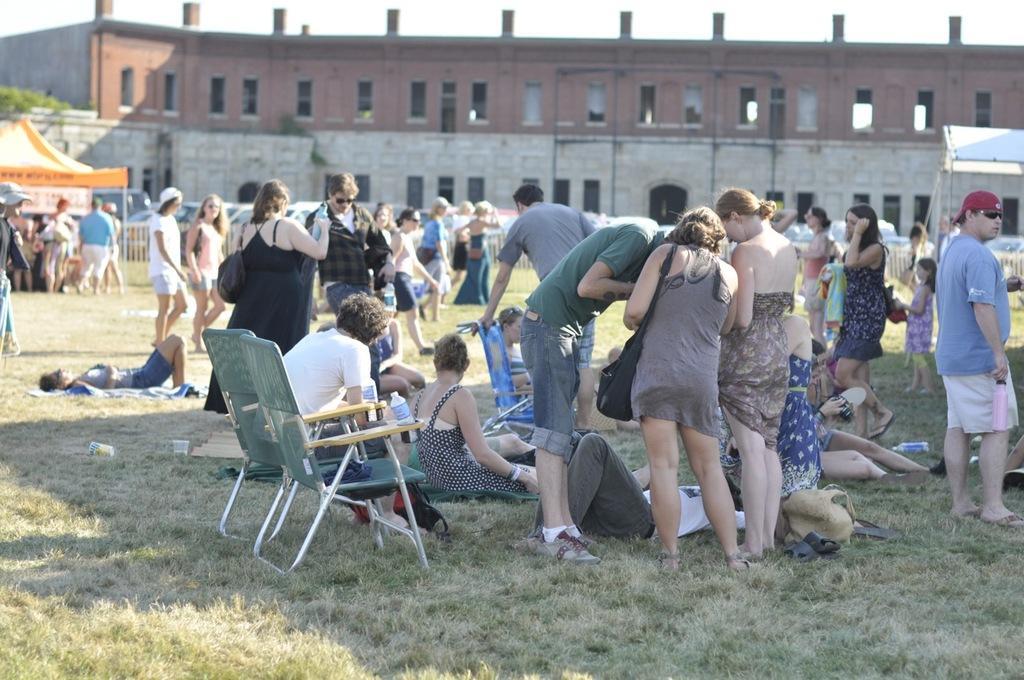In one or two sentences, can you explain what this image depicts? In this image I see lot of people, in which few of them are sitting on the chairs, few of them are lying on the grass and few of them are standing. In the background I see the building, few plants, a tent, and few cars. 